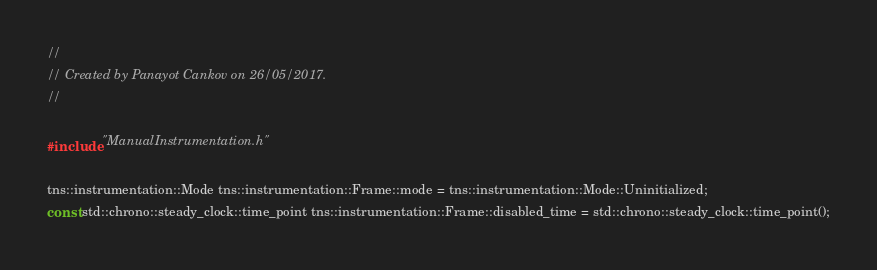<code> <loc_0><loc_0><loc_500><loc_500><_ObjectiveC_>//
// Created by Panayot Cankov on 26/05/2017.
//

#include "ManualInstrumentation.h"

tns::instrumentation::Mode tns::instrumentation::Frame::mode = tns::instrumentation::Mode::Uninitialized;
const std::chrono::steady_clock::time_point tns::instrumentation::Frame::disabled_time = std::chrono::steady_clock::time_point();
</code> 